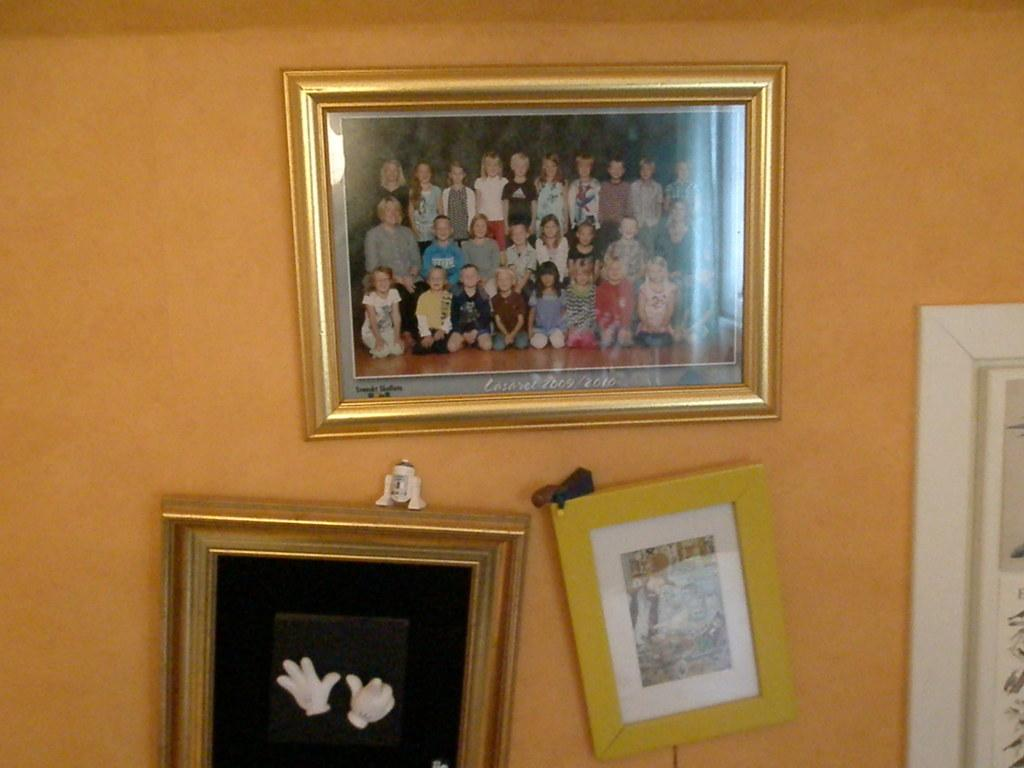Provide a one-sentence caption for the provided image. a class photo that was taken in 2009. 